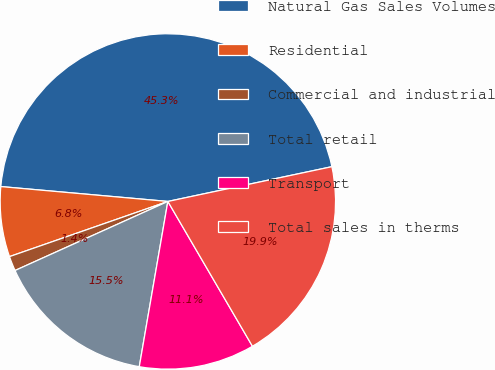Convert chart to OTSL. <chart><loc_0><loc_0><loc_500><loc_500><pie_chart><fcel>Natural Gas Sales Volumes<fcel>Residential<fcel>Commercial and industrial<fcel>Total retail<fcel>Transport<fcel>Total sales in therms<nl><fcel>45.26%<fcel>6.75%<fcel>1.42%<fcel>15.52%<fcel>11.14%<fcel>19.91%<nl></chart> 